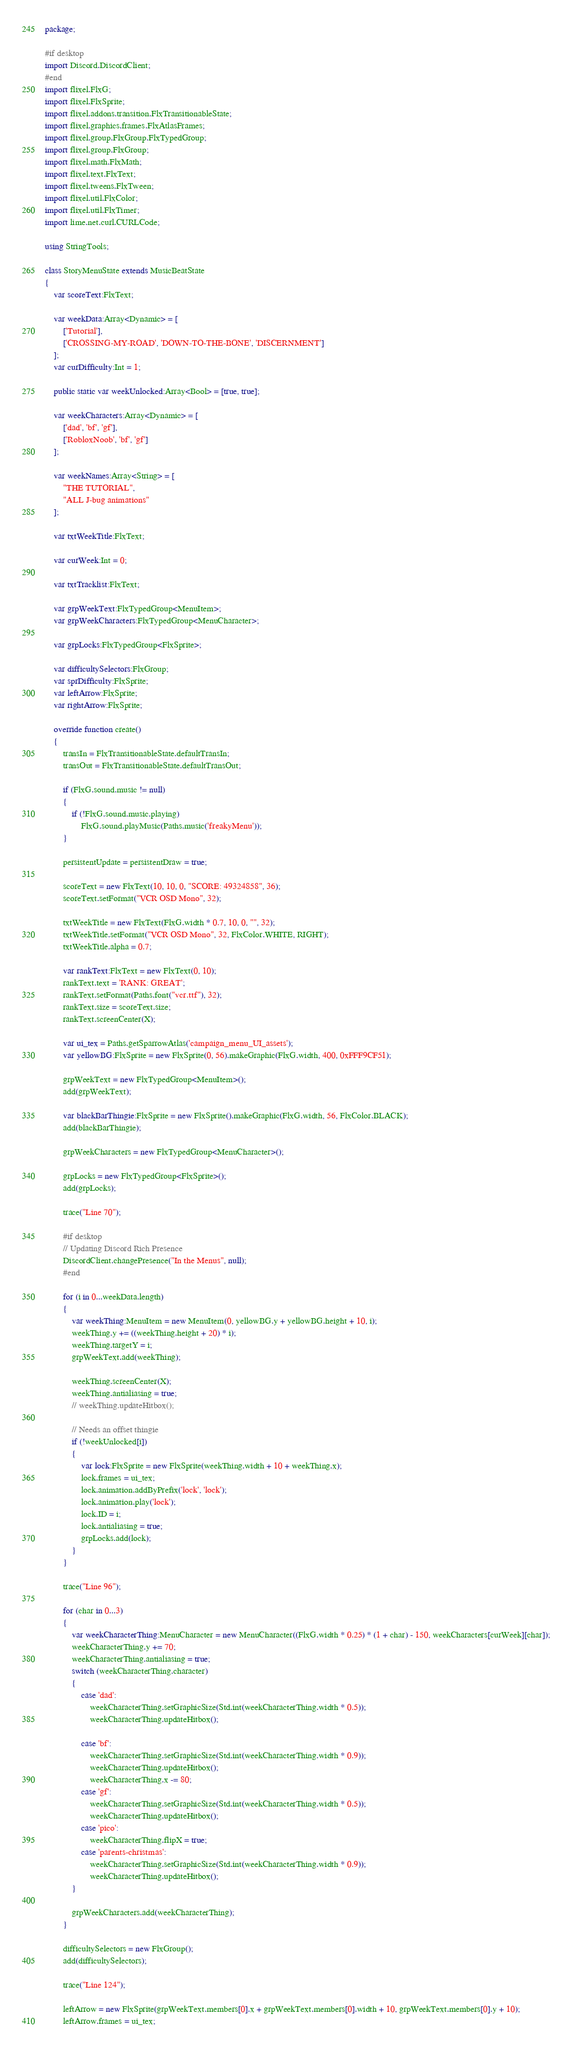Convert code to text. <code><loc_0><loc_0><loc_500><loc_500><_Haxe_>package;

#if desktop
import Discord.DiscordClient;
#end
import flixel.FlxG;
import flixel.FlxSprite;
import flixel.addons.transition.FlxTransitionableState;
import flixel.graphics.frames.FlxAtlasFrames;
import flixel.group.FlxGroup.FlxTypedGroup;
import flixel.group.FlxGroup;
import flixel.math.FlxMath;
import flixel.text.FlxText;
import flixel.tweens.FlxTween;
import flixel.util.FlxColor;
import flixel.util.FlxTimer;
import lime.net.curl.CURLCode;

using StringTools;

class StoryMenuState extends MusicBeatState
{
	var scoreText:FlxText;

	var weekData:Array<Dynamic> = [
		['Tutorial'],
		['CROSSING-MY-ROAD', 'DOWN-TO-THE-BONE', 'DISCERNMENT']
	];
	var curDifficulty:Int = 1;

	public static var weekUnlocked:Array<Bool> = [true, true];

	var weekCharacters:Array<Dynamic> = [
		['dad', 'bf', 'gf'],
		['RobloxNoob', 'bf', 'gf']
	];

	var weekNames:Array<String> = [
		"THE TUTORIAL",
		"ALL J-bug animations"
	];

	var txtWeekTitle:FlxText;

	var curWeek:Int = 0;

	var txtTracklist:FlxText;

	var grpWeekText:FlxTypedGroup<MenuItem>;
	var grpWeekCharacters:FlxTypedGroup<MenuCharacter>;

	var grpLocks:FlxTypedGroup<FlxSprite>;

	var difficultySelectors:FlxGroup;
	var sprDifficulty:FlxSprite;
	var leftArrow:FlxSprite;
	var rightArrow:FlxSprite;

	override function create()
	{
		transIn = FlxTransitionableState.defaultTransIn;
		transOut = FlxTransitionableState.defaultTransOut;

		if (FlxG.sound.music != null)
		{
			if (!FlxG.sound.music.playing)
				FlxG.sound.playMusic(Paths.music('freakyMenu'));
		}

		persistentUpdate = persistentDraw = true;

		scoreText = new FlxText(10, 10, 0, "SCORE: 49324858", 36);
		scoreText.setFormat("VCR OSD Mono", 32);

		txtWeekTitle = new FlxText(FlxG.width * 0.7, 10, 0, "", 32);
		txtWeekTitle.setFormat("VCR OSD Mono", 32, FlxColor.WHITE, RIGHT);
		txtWeekTitle.alpha = 0.7;

		var rankText:FlxText = new FlxText(0, 10);
		rankText.text = 'RANK: GREAT';
		rankText.setFormat(Paths.font("vcr.ttf"), 32);
		rankText.size = scoreText.size;
		rankText.screenCenter(X);

		var ui_tex = Paths.getSparrowAtlas('campaign_menu_UI_assets');
		var yellowBG:FlxSprite = new FlxSprite(0, 56).makeGraphic(FlxG.width, 400, 0xFFF9CF51);

		grpWeekText = new FlxTypedGroup<MenuItem>();
		add(grpWeekText);

		var blackBarThingie:FlxSprite = new FlxSprite().makeGraphic(FlxG.width, 56, FlxColor.BLACK);
		add(blackBarThingie);

		grpWeekCharacters = new FlxTypedGroup<MenuCharacter>();

		grpLocks = new FlxTypedGroup<FlxSprite>();
		add(grpLocks);

		trace("Line 70");
		
		#if desktop
		// Updating Discord Rich Presence
		DiscordClient.changePresence("In the Menus", null);
		#end

		for (i in 0...weekData.length)
		{
			var weekThing:MenuItem = new MenuItem(0, yellowBG.y + yellowBG.height + 10, i);
			weekThing.y += ((weekThing.height + 20) * i);
			weekThing.targetY = i;
			grpWeekText.add(weekThing);

			weekThing.screenCenter(X);
			weekThing.antialiasing = true;
			// weekThing.updateHitbox();

			// Needs an offset thingie
			if (!weekUnlocked[i])
			{
				var lock:FlxSprite = new FlxSprite(weekThing.width + 10 + weekThing.x);
				lock.frames = ui_tex;
				lock.animation.addByPrefix('lock', 'lock');
				lock.animation.play('lock');
				lock.ID = i;
				lock.antialiasing = true;
				grpLocks.add(lock);
			}
		}

		trace("Line 96");

		for (char in 0...3)
		{
			var weekCharacterThing:MenuCharacter = new MenuCharacter((FlxG.width * 0.25) * (1 + char) - 150, weekCharacters[curWeek][char]);
			weekCharacterThing.y += 70;
			weekCharacterThing.antialiasing = true;
			switch (weekCharacterThing.character)
			{
				case 'dad':
					weekCharacterThing.setGraphicSize(Std.int(weekCharacterThing.width * 0.5));
					weekCharacterThing.updateHitbox();

				case 'bf':
					weekCharacterThing.setGraphicSize(Std.int(weekCharacterThing.width * 0.9));
					weekCharacterThing.updateHitbox();
					weekCharacterThing.x -= 80;
				case 'gf':
					weekCharacterThing.setGraphicSize(Std.int(weekCharacterThing.width * 0.5));
					weekCharacterThing.updateHitbox();
				case 'pico':
					weekCharacterThing.flipX = true;
				case 'parents-christmas':
					weekCharacterThing.setGraphicSize(Std.int(weekCharacterThing.width * 0.9));
					weekCharacterThing.updateHitbox();
			}

			grpWeekCharacters.add(weekCharacterThing);
		}

		difficultySelectors = new FlxGroup();
		add(difficultySelectors);

		trace("Line 124");

		leftArrow = new FlxSprite(grpWeekText.members[0].x + grpWeekText.members[0].width + 10, grpWeekText.members[0].y + 10);
		leftArrow.frames = ui_tex;</code> 